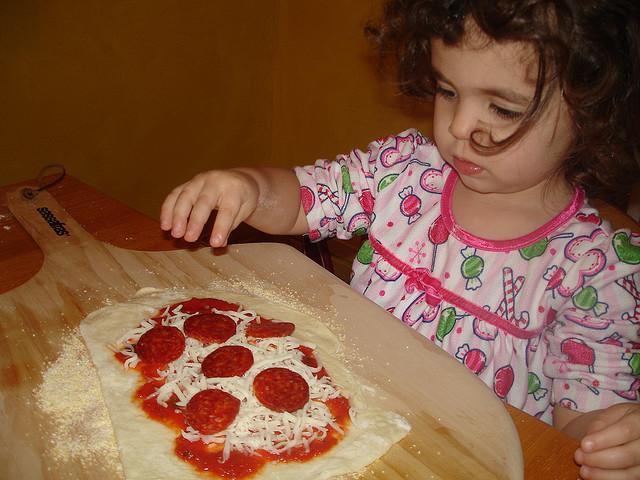Verify the accuracy of this image caption: "The pizza is at the edge of the dining table.".
Answer yes or no. Yes. 